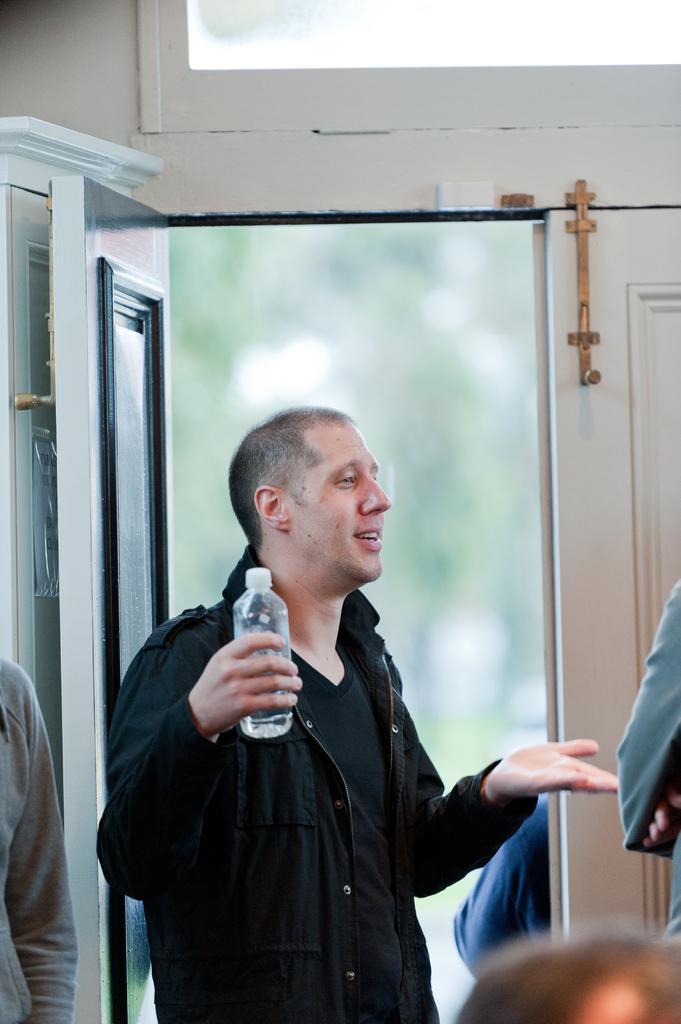Could you give a brief overview of what you see in this image? In this image we can see a man standing and smiling, and holding a water bottle in the hand, and in front here is the door, and here are the persons standing. 